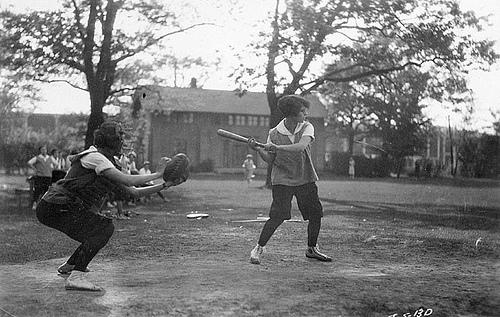What sport are they playing?
Write a very short answer. Baseball. How old is this photo?
Quick response, please. Old. Are these women?
Give a very brief answer. Yes. What activity are these people planning to do?
Concise answer only. Baseball. 